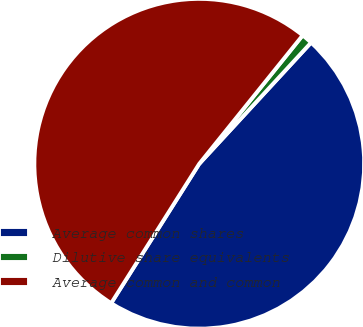Convert chart to OTSL. <chart><loc_0><loc_0><loc_500><loc_500><pie_chart><fcel>Average common shares<fcel>Dilutive share equivalents<fcel>Average common and common<nl><fcel>47.11%<fcel>1.07%<fcel>51.82%<nl></chart> 